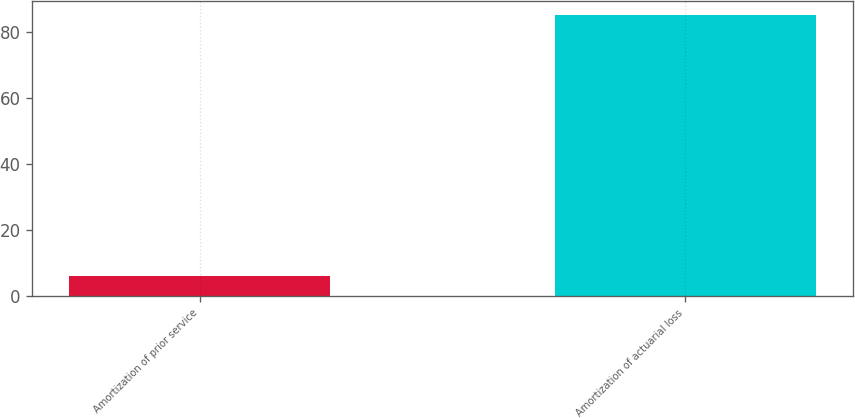Convert chart. <chart><loc_0><loc_0><loc_500><loc_500><bar_chart><fcel>Amortization of prior service<fcel>Amortization of actuarial loss<nl><fcel>6<fcel>85<nl></chart> 